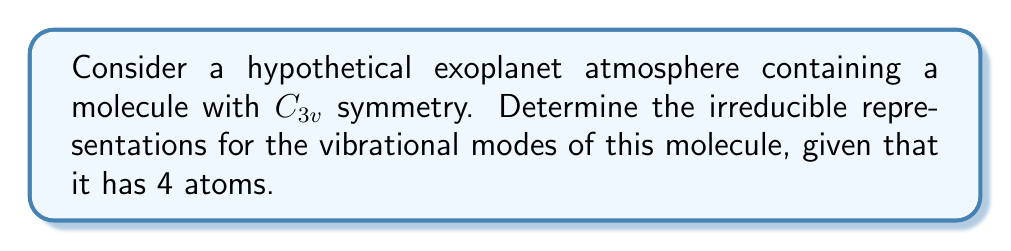Could you help me with this problem? To determine the irreducible representations for the vibrational modes of a molecule with $C_{3v}$ symmetry and 4 atoms, we'll follow these steps:

1. Calculate the number of vibrational modes:
   For a molecule with N atoms, the number of vibrational modes is $3N - 6$ for non-linear molecules.
   $$3N - 6 = 3(4) - 6 = 6$$

2. Determine the reducible representation $\Gamma_{vib}$ using the following formula:
   $$\Gamma_{vib} = 3\Gamma_{R} - \Gamma_{T} - \Gamma_{R}$$
   where $\Gamma_{R}$ is the reducible representation of the cartesian coordinates, $\Gamma_{T}$ is the translation, and $\Gamma_{R}$ is the rotation.

3. For $C_{3v}$ symmetry, the character table is:
   $$
   \begin{array}{c|ccc}
   C_{3v} & E & 2C_3 & 3\sigma_v \\
   \hline
   A_1 & 1 & 1 & 1 \\
   A_2 & 1 & 1 & -1 \\
   E & 2 & -1 & 0
   \end{array}
   $$

4. Calculate $\Gamma_{R}$:
   $$\Gamma_{R}: 12 \quad 0 \quad 2$$

5. Determine $\Gamma_{T}$ and $\Gamma_{R}$:
   $$\Gamma_{T} = A_1 + E$$
   $$\Gamma_{R} = A_2 + E$$

6. Calculate $\Gamma_{vib}$:
   $$\Gamma_{vib} = 3(12, 0, 2) - (1, 1, 1) - (1, 1, -1) - (2, -1, 0) - (2, -1, 0)$$
   $$\Gamma_{vib} = (36, 0, 6) - (1, 1, 1) - (1, 1, -1) - (4, -2, 0)$$
   $$\Gamma_{vib} = (30, 0, 6)$$

7. Decompose $\Gamma_{vib}$ into irreducible representations:
   $$a(A_1) + b(A_2) + c(E)$$
   Solving the system of equations:
   $$a + b + 2c = 30$$
   $$a + b - c = 0$$
   $$a - b = 6$$

   We get: $a = 3, b = 1, c = 2$

Therefore, the irreducible representations for the vibrational modes are:
$$\Gamma_{vib} = 3A_1 + A_2 + 2E$$
Answer: $3A_1 + A_2 + 2E$ 